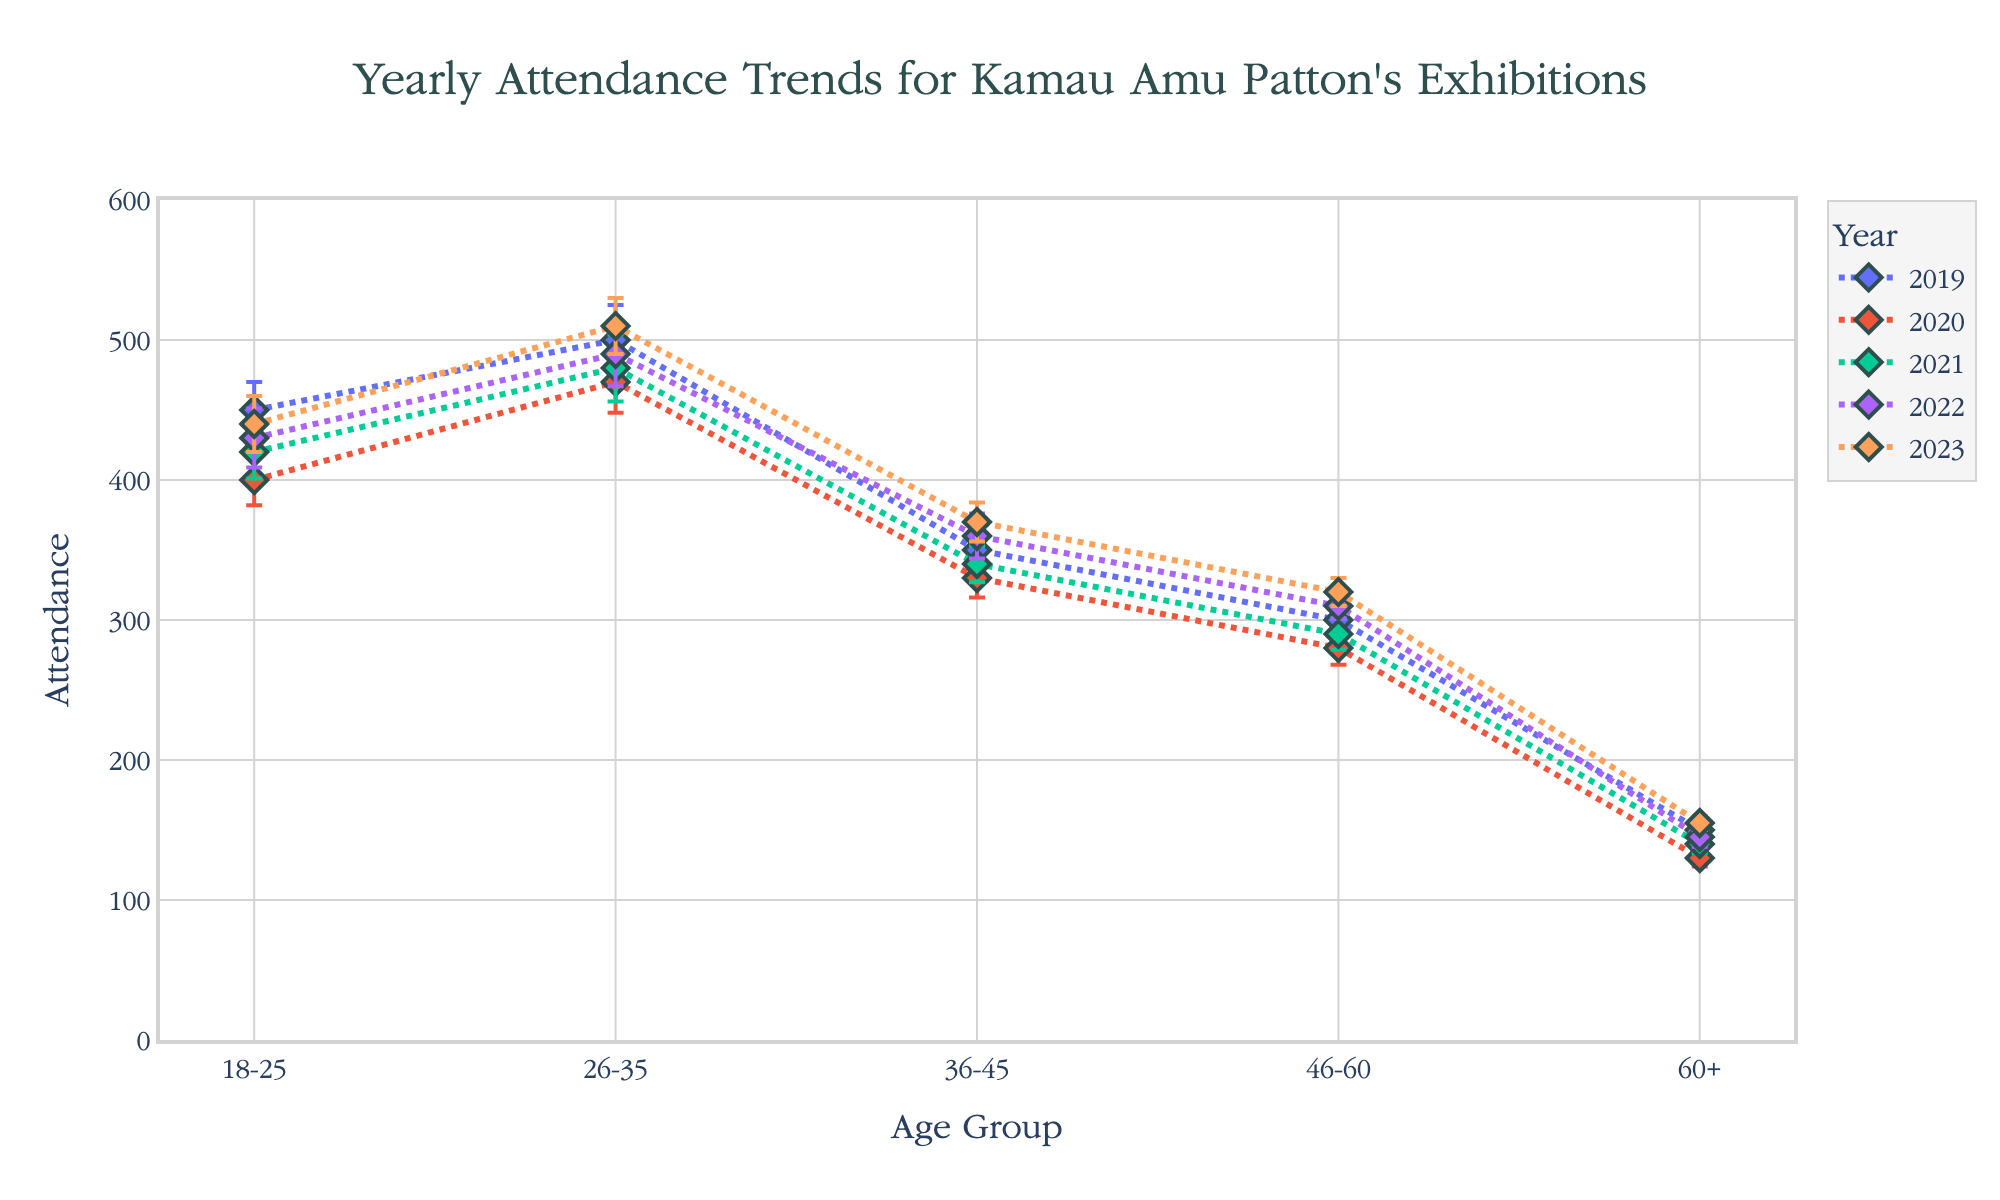what is the title of the figure? The title of the figure is prominently displayed at the top in a larger font size.
Answer: "Yearly Attendance Trends for Kamau Amu Patton's Exhibitions" Which color represents the year 2019 in the plot? Each year in the plot is represented by a different line and marker color. To identify 2019, locate the legend and match the 2019 label with its corresponding color and line style
Answer: Refer to plot (color by legend, typically first entry) What is the attendance for the 26-35 demographic in 2023? Locate the line and markers for 2023 in the plot. Follow the line to the 26-35 demographic point and read the attendance value from the y-axis.
Answer: 510 How has the attendance for the 60+ demographic changed from 2019 to 2023? Locate both 2019 and 2023 lines for the 60+ demographic and compare their attendance values by reading from the y-axis at those points.
Answer: Increased from 150 to 155 What is the demographic group with the highest attendance in 2021? Identify the line for 2021 and examine the attendance values among different demographics, then identify the one with the highest y-value.
Answer: 26-35 What's the mean attendance for the 36-45 demographic across 2019 and 2020? Add the attendance values for the 36-45 group for both years and divide by 2: (350 + 330) / 2.
Answer: 340 Which year shows the least attendance for the 46-60 demographic? Compare the y-values for the 46-60 demographic across all years and identify the smallest value.
Answer: 2020 How much did attendance for the 18-25 demographic differ between 2019 and 2022? Find the attendance values for the 18-25 demographic in 2019 and 2022 (450 and 430), then subtract the smaller number from the larger.
Answer: Decreased by 20 What’s the range of the attendance values displayed in the plot? Identify the minimum and maximum attendance values on the y-axis across all demographics and years.
Answer: 130 to 510 